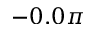Convert formula to latex. <formula><loc_0><loc_0><loc_500><loc_500>- 0 . 0 \pi</formula> 